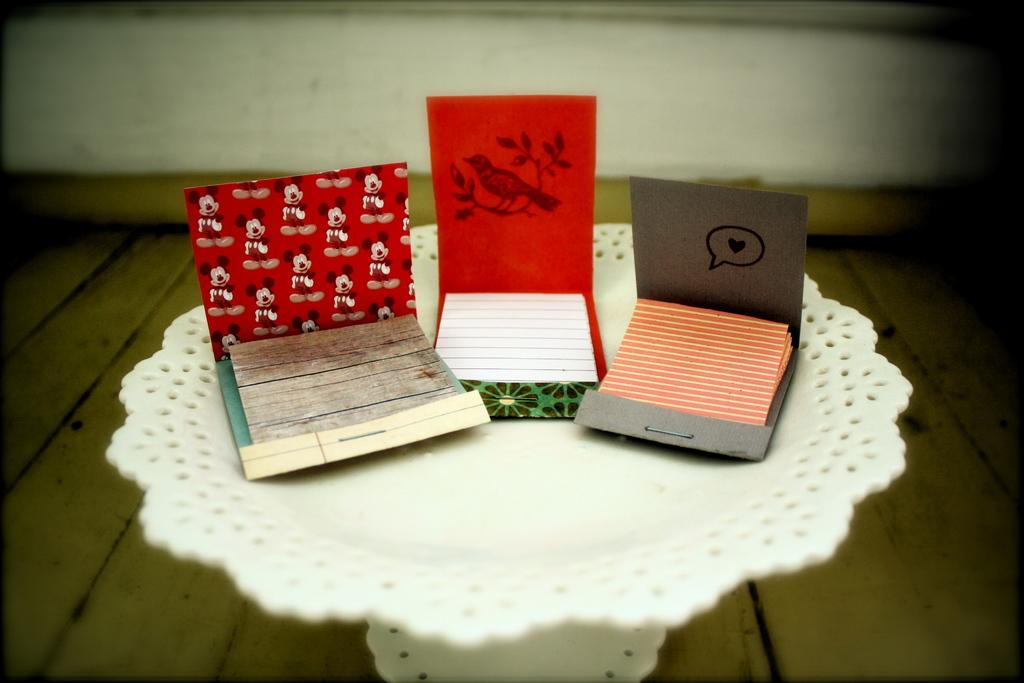What type of surface is the table in the image resting on? The table is on a wooden floor. What objects can be seen on the table in the image? There are three envelopes on the table. What is inside the envelopes? The envelopes contain papers. Are there any cobwebs visible on the table in the image? There is no mention of cobwebs in the provided facts, so we cannot determine if any are present in the image. 